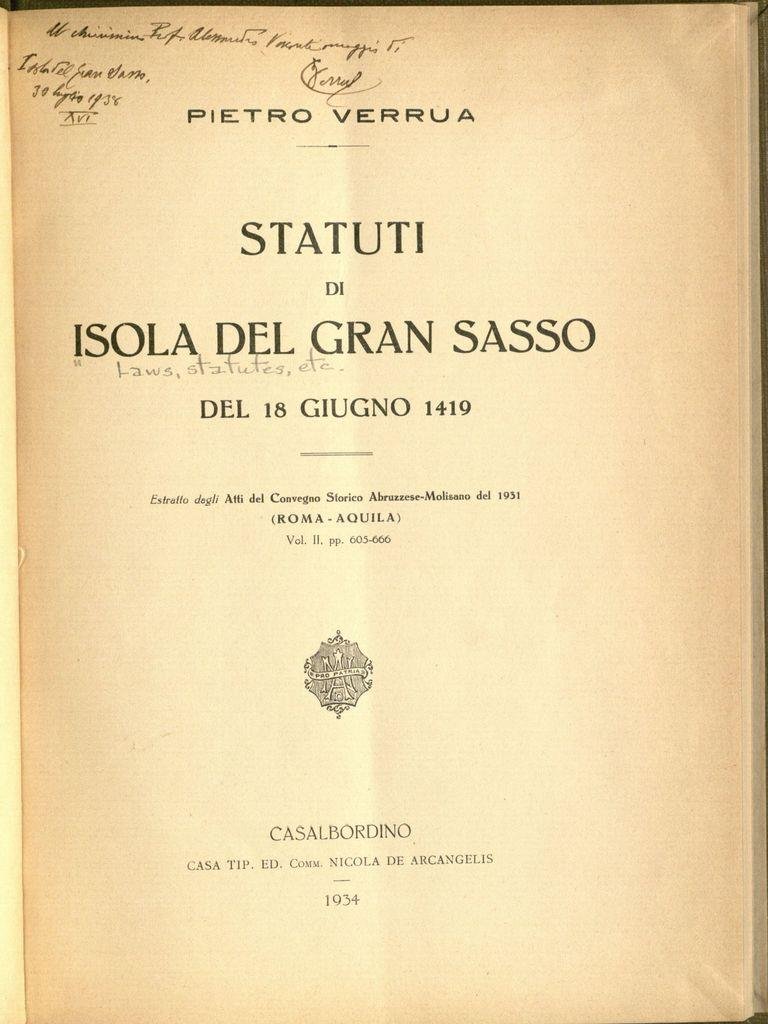<image>
Provide a brief description of the given image. the cover page for the book titled "Statuti Di Isola Del Gran Sasso". 